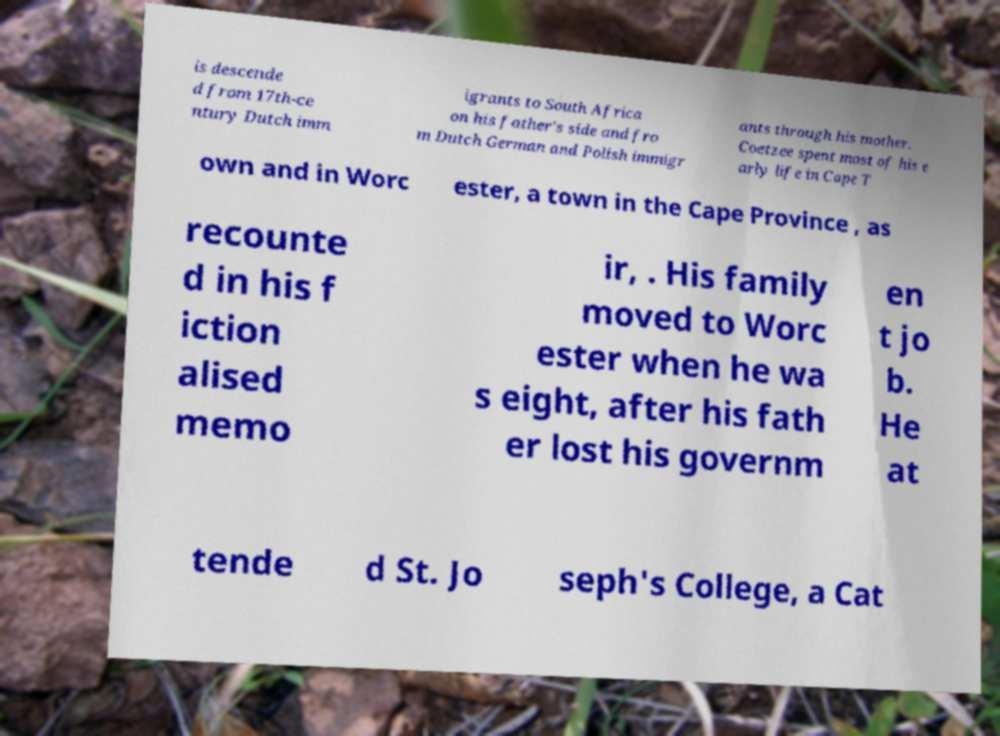Please identify and transcribe the text found in this image. is descende d from 17th-ce ntury Dutch imm igrants to South Africa on his father's side and fro m Dutch German and Polish immigr ants through his mother. Coetzee spent most of his e arly life in Cape T own and in Worc ester, a town in the Cape Province , as recounte d in his f iction alised memo ir, . His family moved to Worc ester when he wa s eight, after his fath er lost his governm en t jo b. He at tende d St. Jo seph's College, a Cat 